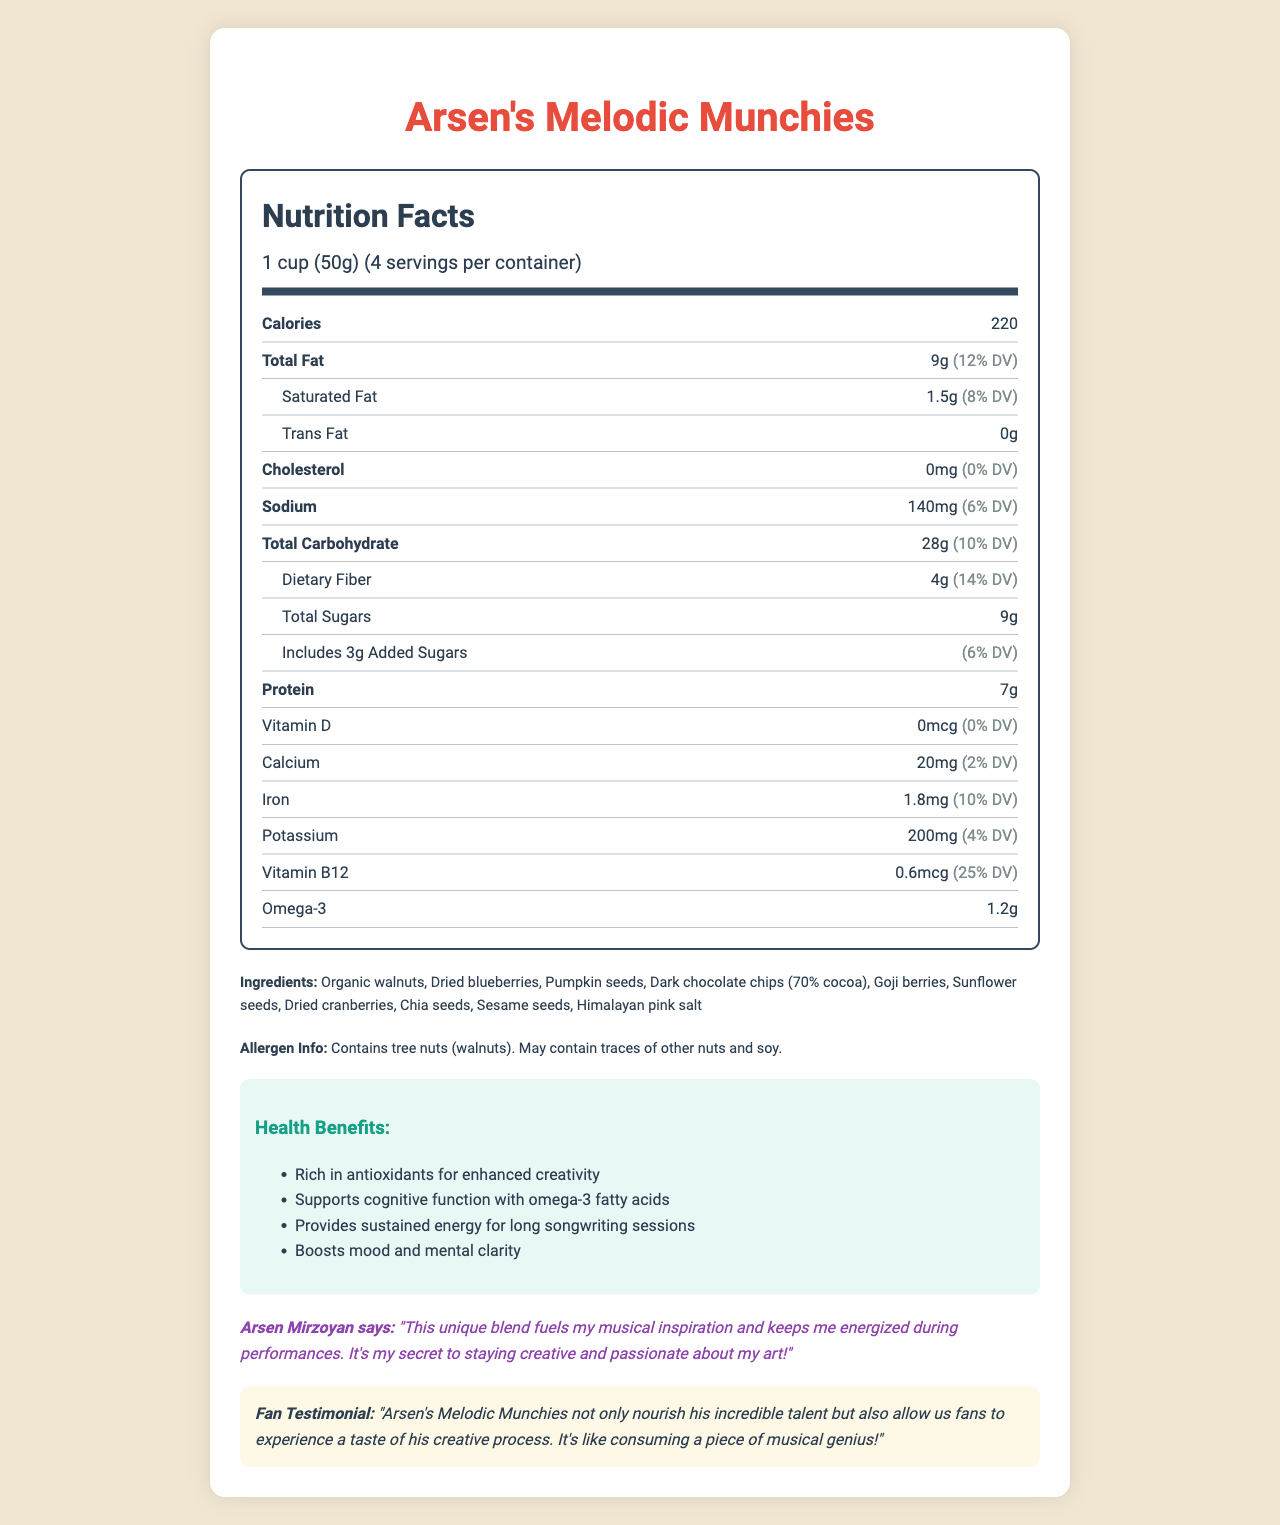who endorses Arsen's Melodic Munchies? According to the document, Arsen Mirzoyan himself endorses the product.
Answer: Arsen Mirzoyan what is the serving size of Arsen's Melodic Munchies? The serving size is clearly mentioned as 1 cup (50g) in the serving information.
Answer: 1 cup (50g) how much omega-3 is included per serving? The omega-3 content per serving is listed as 1.2 grams.
Answer: 1.2g what are the total carbohydrates in a serving? The total carbohydrates in a single serving are noted as 28 grams.
Answer: 28g how many servings are in one container? According to the document, there are 4 servings per container.
Answer: 4 what is the daily value percentage of Vitamin B12 per serving? A. 10% B. 25% C. 50% D. 75% The document lists the daily value percentage of Vitamin B12 as 25%.
Answer: B. 25% which ingredient is not listed in Arsen's Melodic Munchies? i. Dark chocolate chips ii. Dried blueberries iii. Almonds iv. Chia seeds Almonds are not listed among the ingredients on the document.
Answer: iii. Almonds is there any cholesterol in Arsen's Melodic Munchies? The document states that there is 0 mg of cholesterol.
Answer: No if someone is allergic to nuts, can they consume Arsen's Melodic Munchies safely? The allergen information mentions that the product contains tree nuts (walnuts) and may contain traces of other nuts, which could be unsafe.
Answer: No where is the fan testimonial featured? The fan testimonial is included at the end of the document, under the fan testimonial section.
Answer: At the end of the document what are the primary benefits of consuming Arsen's Melodic Munchies according to the health claims? The document mentions these four main health benefits.
Answer: Rich in antioxidants, supports cognitive function, provides sustained energy, boosts mood and mental clarity how many grams of protein are in one serving of Arsen's Melodic Munchies? The protein content per serving is 7 grams as listed in the document.
Answer: 7g describe the main idea of Arsen's Melodic Munchies nutritional document? The document highlights the nutritional aspects, health benefits, and endorsements for a special blend of brain-boosting foods designed to fuel creativity and energy, supported by arson Mirzoyan and a fan testimonial.
Answer: Arsen's Melodic Munchies is a specially formulated blend of brain-boosting foods that Arsen Mirzoyan endorses for its health benefits and creative support. The document presents detailed nutritional information, ingredients, allergens, health claims, and testimonials. how many cups are there in one container? The document does not provide direct information on the number of cups per container. It only mentions the serving size and the number of servings per container.
Answer: Not enough information 